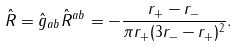<formula> <loc_0><loc_0><loc_500><loc_500>\hat { R } = \hat { g } _ { a b } \hat { R } ^ { a b } = - \frac { r _ { + } - r _ { - } } { \pi r _ { + } ( 3 r _ { - } - r _ { + } ) ^ { 2 } } .</formula> 